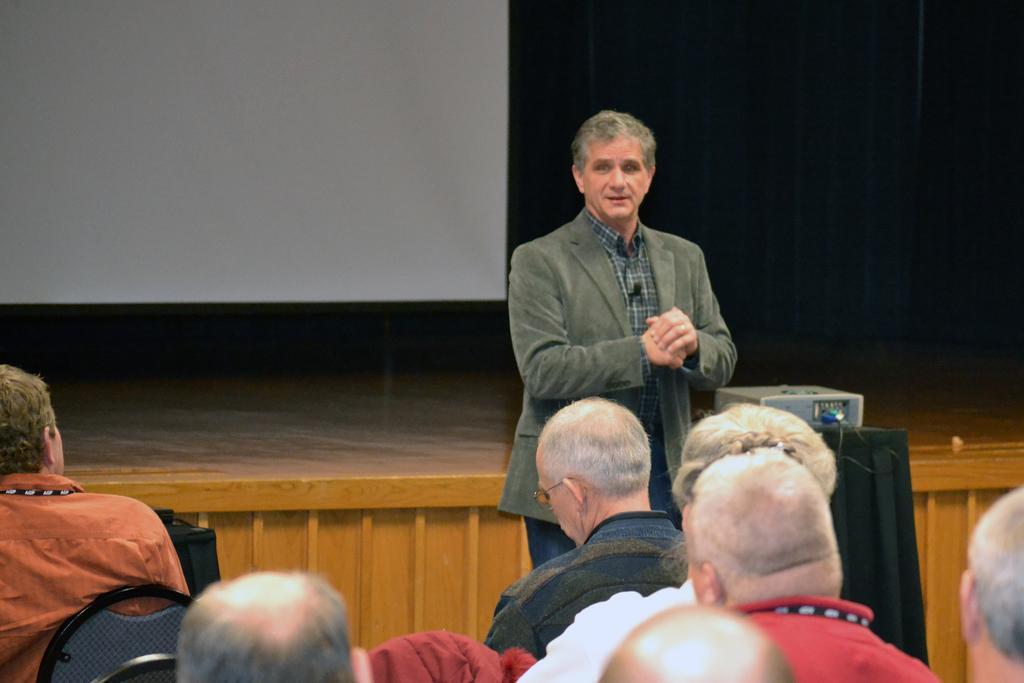Can you describe this image briefly? In this image, we can see a man standing, he is wearing a coat, there are some people sitting on the chairs, we can see a projector and there is a stage. 